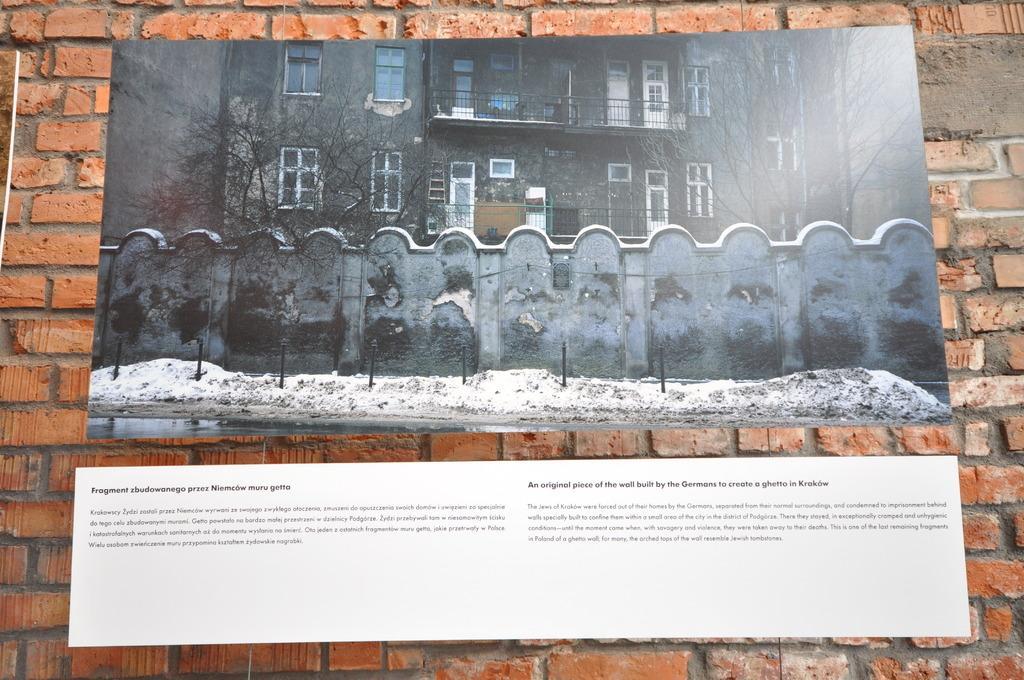Can you describe this image briefly? In this image there is a wall of red bricks. There are boards of pictures and text on the wall. There are buildings, trees, walls and snow on the ground in the picture. 